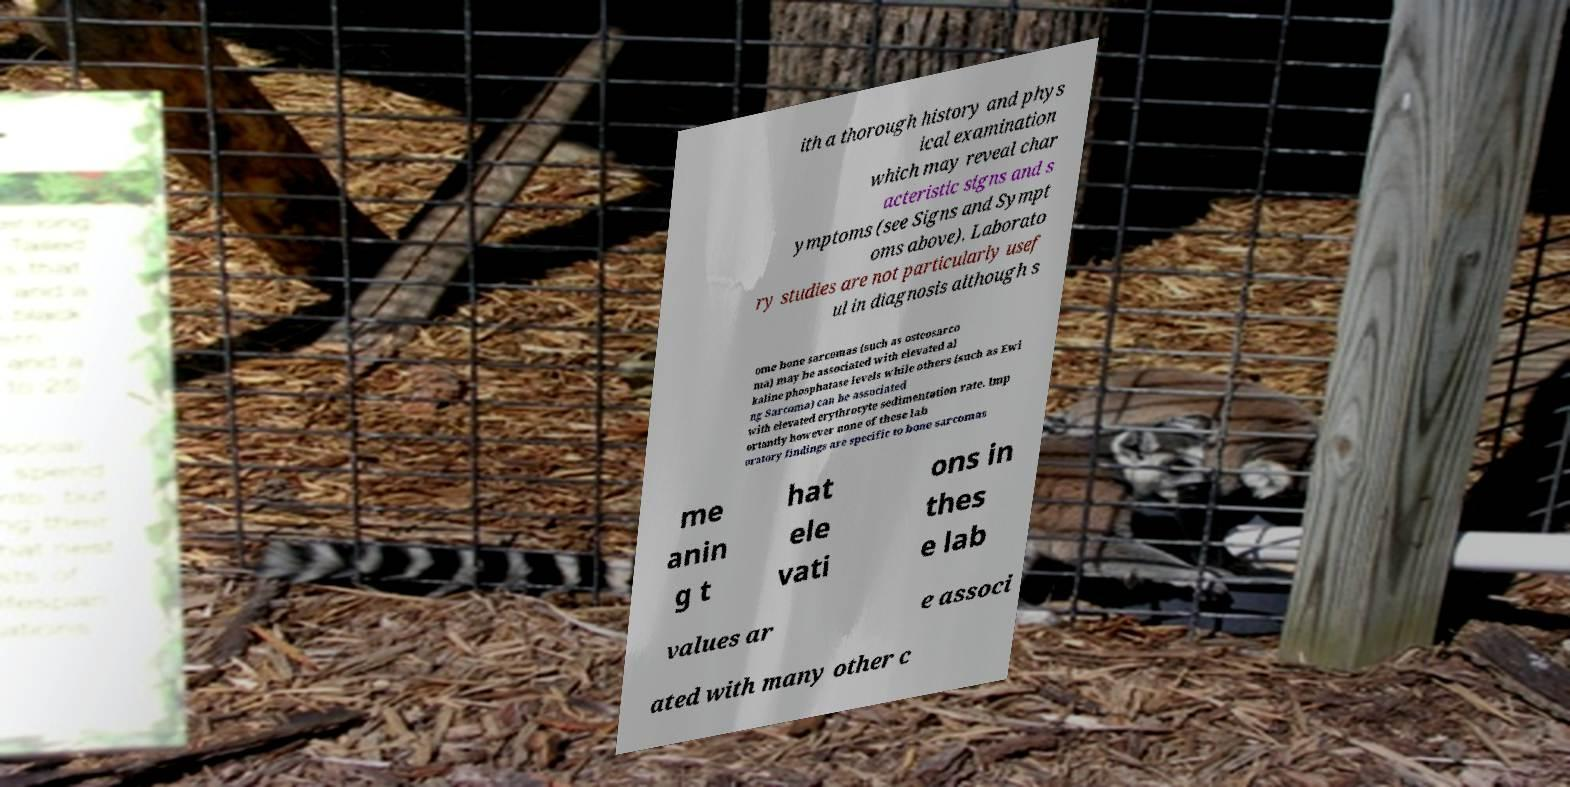Could you extract and type out the text from this image? ith a thorough history and phys ical examination which may reveal char acteristic signs and s ymptoms (see Signs and Sympt oms above). Laborato ry studies are not particularly usef ul in diagnosis although s ome bone sarcomas (such as osteosarco ma) may be associated with elevated al kaline phosphatase levels while others (such as Ewi ng Sarcoma) can be associated with elevated erythrocyte sedimentation rate. Imp ortantly however none of these lab oratory findings are specific to bone sarcomas me anin g t hat ele vati ons in thes e lab values ar e associ ated with many other c 